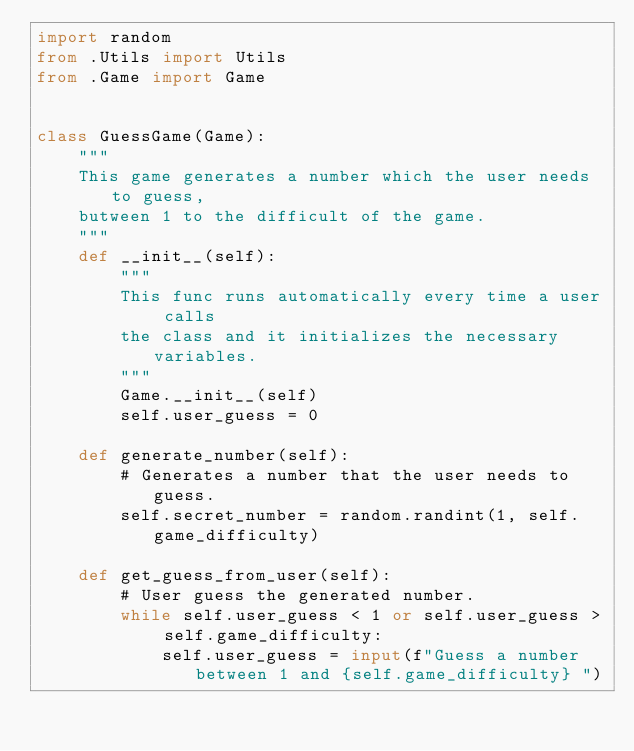Convert code to text. <code><loc_0><loc_0><loc_500><loc_500><_Python_>import random
from .Utils import Utils
from .Game import Game


class GuessGame(Game):
    """
    This game generates a number which the user needs to guess,
    butween 1 to the difficult of the game.
    """
    def __init__(self):
        """
        This func runs automatically every time a user calls
        the class and it initializes the necessary variables.
        """
        Game.__init__(self)
        self.user_guess = 0

    def generate_number(self):
        # Generates a number that the user needs to guess.
        self.secret_number = random.randint(1, self.game_difficulty)

    def get_guess_from_user(self):
        # User guess the generated number.
        while self.user_guess < 1 or self.user_guess > self.game_difficulty:
            self.user_guess = input(f"Guess a number between 1 and {self.game_difficulty} ")</code> 